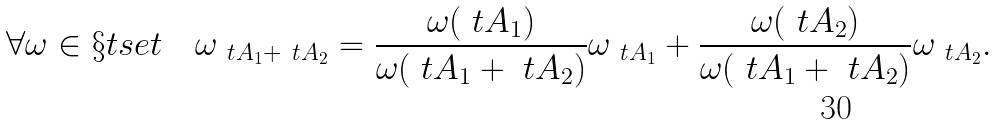Convert formula to latex. <formula><loc_0><loc_0><loc_500><loc_500>\forall \omega \in \S t s e t \quad \omega _ { \ t A _ { 1 } + \ t A _ { 2 } } = \frac { \omega ( \ t A _ { 1 } ) } { \omega ( \ t A _ { 1 } + \ t A _ { 2 } ) } \omega _ { \ t A _ { 1 } } + \frac { \omega ( \ t A _ { 2 } ) } { \omega ( \ t A _ { 1 } + \ t A _ { 2 } ) } \omega _ { \ t A _ { 2 } } .</formula> 